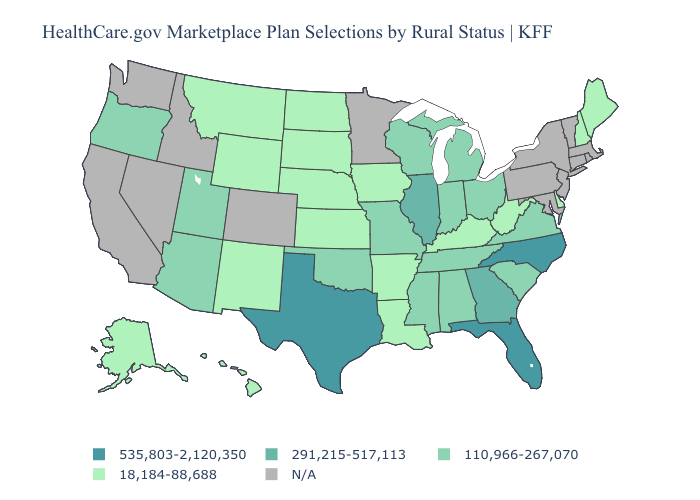Is the legend a continuous bar?
Give a very brief answer. No. Which states have the lowest value in the West?
Answer briefly. Alaska, Hawaii, Montana, New Mexico, Wyoming. Does Louisiana have the lowest value in the South?
Write a very short answer. Yes. Name the states that have a value in the range 18,184-88,688?
Answer briefly. Alaska, Arkansas, Delaware, Hawaii, Iowa, Kansas, Kentucky, Louisiana, Maine, Montana, Nebraska, New Hampshire, New Mexico, North Dakota, South Dakota, West Virginia, Wyoming. Does Wisconsin have the highest value in the USA?
Keep it brief. No. Name the states that have a value in the range 291,215-517,113?
Write a very short answer. Georgia, Illinois. Name the states that have a value in the range 291,215-517,113?
Answer briefly. Georgia, Illinois. What is the value of Alaska?
Be succinct. 18,184-88,688. Is the legend a continuous bar?
Short answer required. No. Which states have the lowest value in the USA?
Concise answer only. Alaska, Arkansas, Delaware, Hawaii, Iowa, Kansas, Kentucky, Louisiana, Maine, Montana, Nebraska, New Hampshire, New Mexico, North Dakota, South Dakota, West Virginia, Wyoming. What is the lowest value in states that border South Carolina?
Answer briefly. 291,215-517,113. Does Delaware have the highest value in the South?
Answer briefly. No. What is the value of South Dakota?
Concise answer only. 18,184-88,688. 